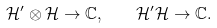Convert formula to latex. <formula><loc_0><loc_0><loc_500><loc_500>\mathcal { H } ^ { \prime } \otimes \mathcal { H } \to \mathbb { C } , \quad \mathcal { H } ^ { \prime } \mathcal { H } \to \mathbb { C } .</formula> 